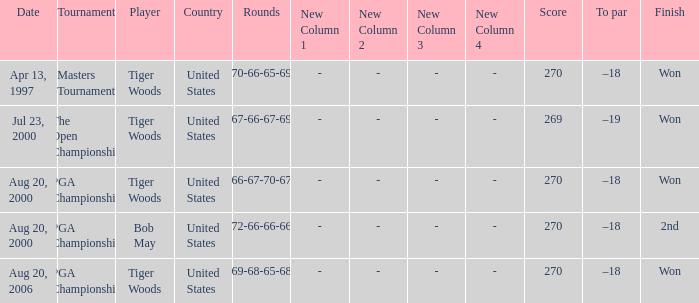What is the worst (highest) score? 270.0. 